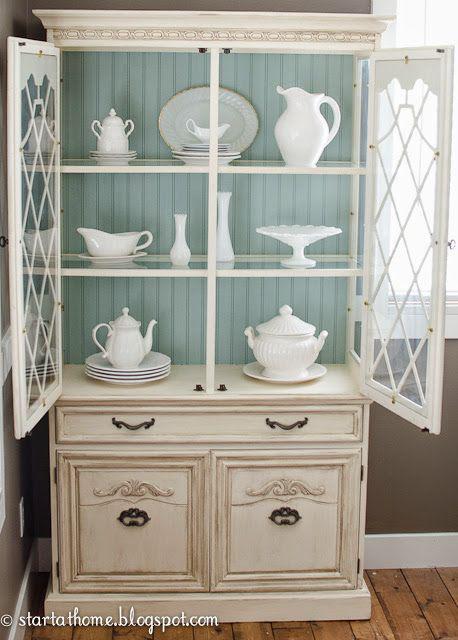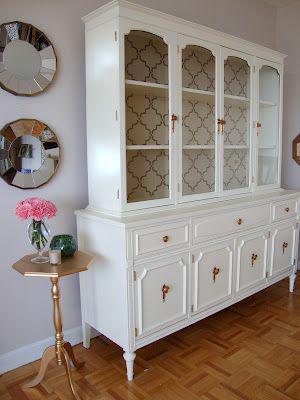The first image is the image on the left, the second image is the image on the right. Given the left and right images, does the statement "One of the cabinets is empty inside." hold true? Answer yes or no. Yes. The first image is the image on the left, the second image is the image on the right. For the images displayed, is the sentence "the right pic furniture piece has 3 or more glass panels" factually correct? Answer yes or no. Yes. 